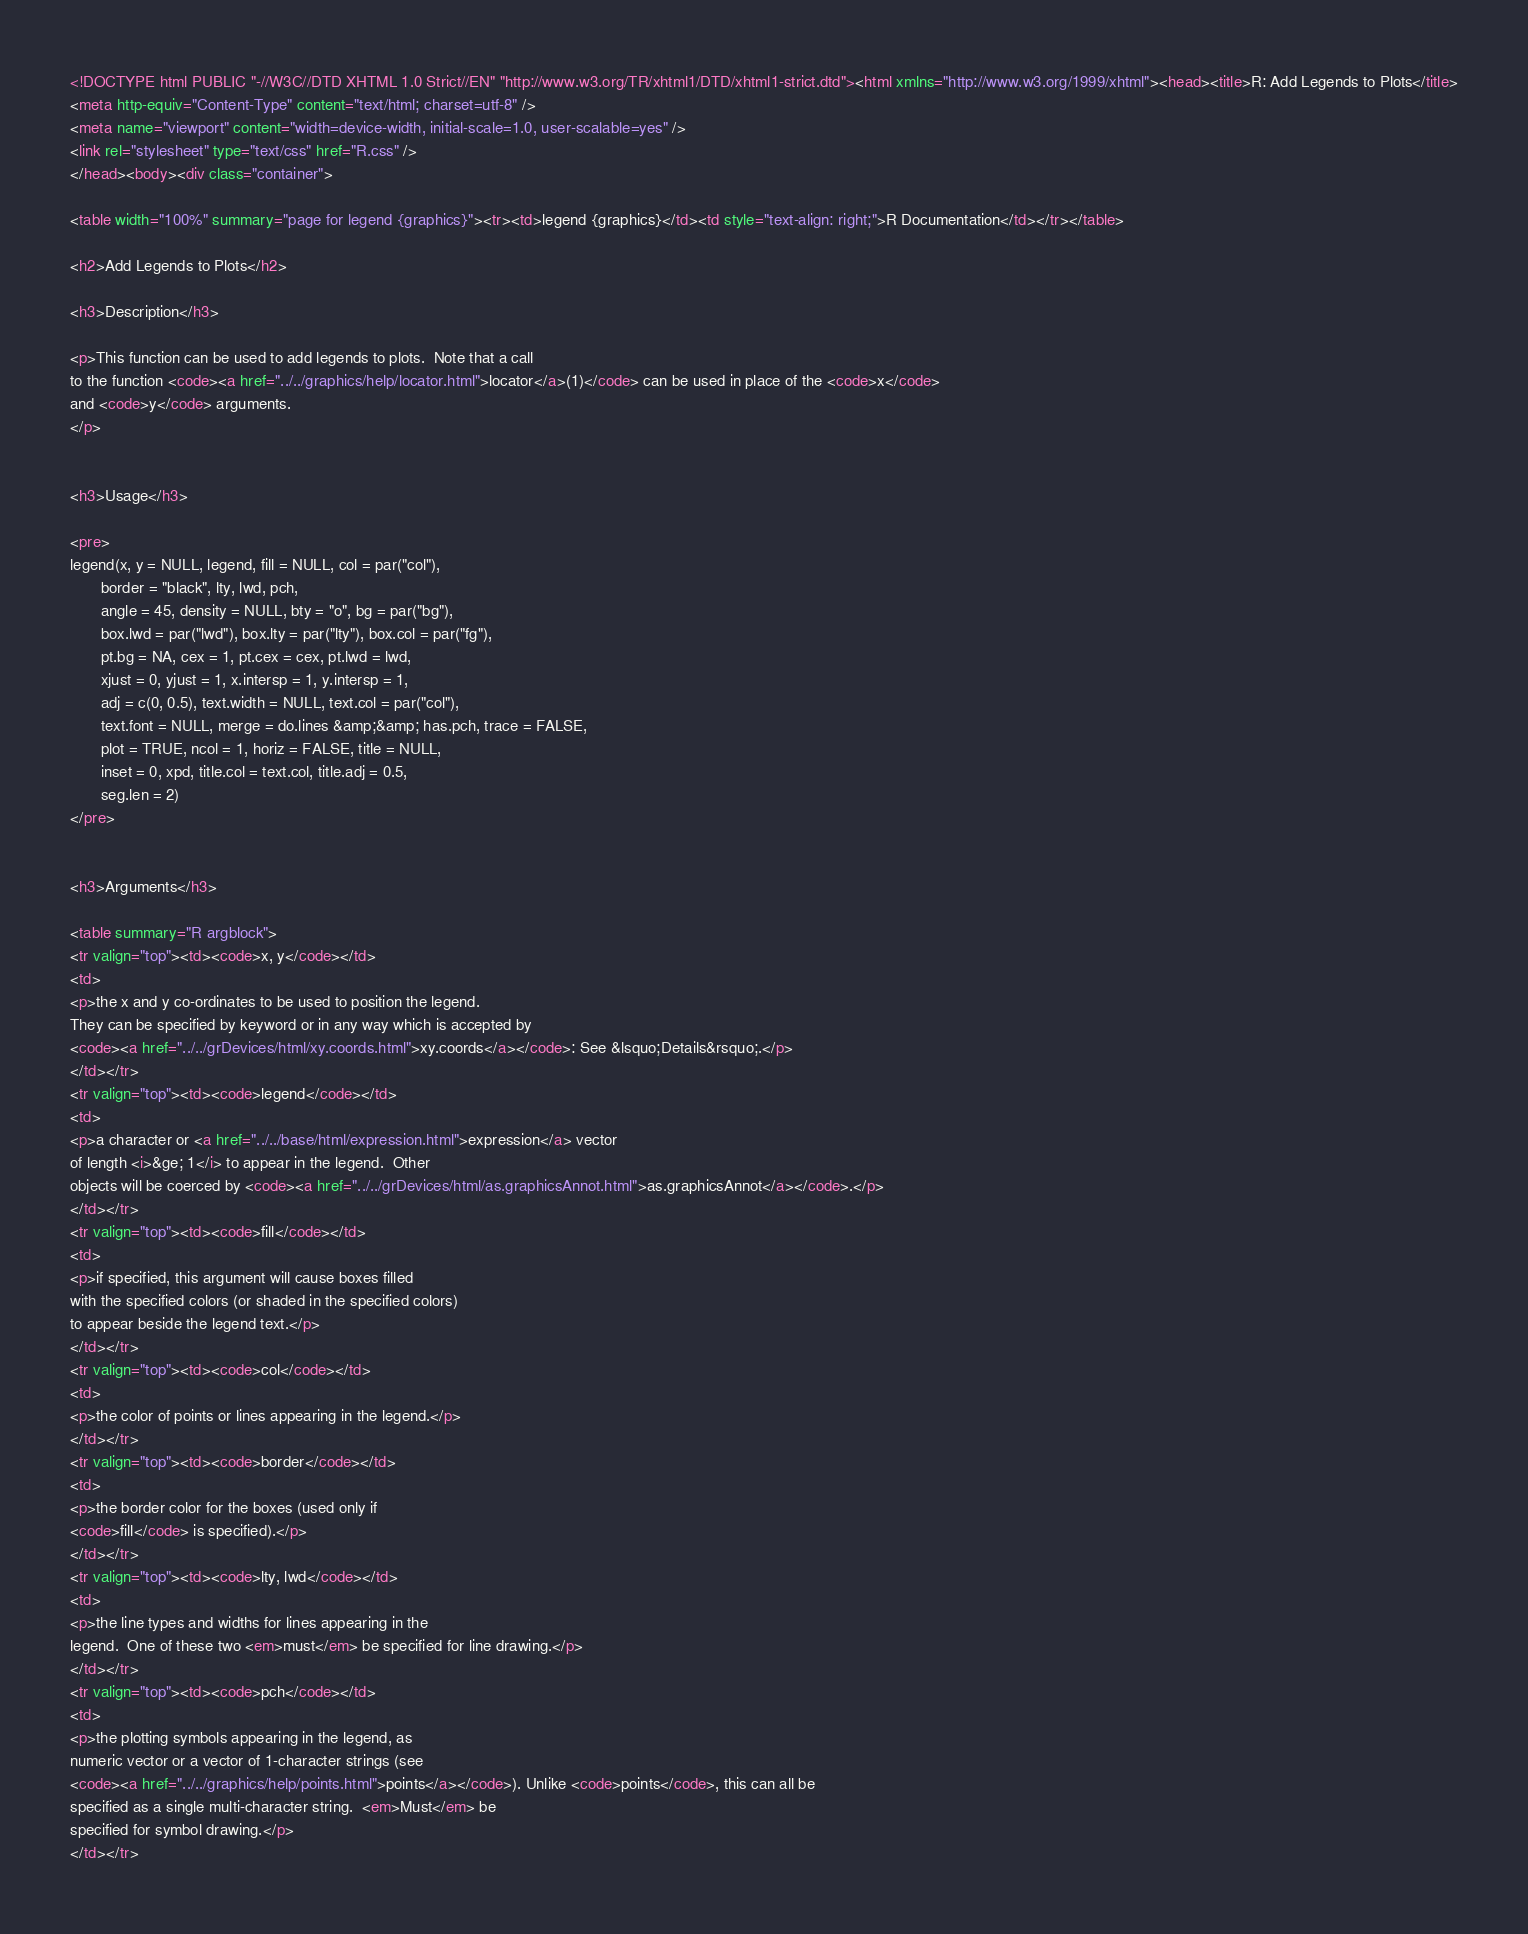Convert code to text. <code><loc_0><loc_0><loc_500><loc_500><_HTML_><!DOCTYPE html PUBLIC "-//W3C//DTD XHTML 1.0 Strict//EN" "http://www.w3.org/TR/xhtml1/DTD/xhtml1-strict.dtd"><html xmlns="http://www.w3.org/1999/xhtml"><head><title>R: Add Legends to Plots</title>
<meta http-equiv="Content-Type" content="text/html; charset=utf-8" />
<meta name="viewport" content="width=device-width, initial-scale=1.0, user-scalable=yes" />
<link rel="stylesheet" type="text/css" href="R.css" />
</head><body><div class="container">

<table width="100%" summary="page for legend {graphics}"><tr><td>legend {graphics}</td><td style="text-align: right;">R Documentation</td></tr></table>

<h2>Add Legends to Plots</h2>

<h3>Description</h3>

<p>This function can be used to add legends to plots.  Note that a call
to the function <code><a href="../../graphics/help/locator.html">locator</a>(1)</code> can be used in place of the <code>x</code>
and <code>y</code> arguments.
</p>


<h3>Usage</h3>

<pre>
legend(x, y = NULL, legend, fill = NULL, col = par("col"),
       border = "black", lty, lwd, pch,
       angle = 45, density = NULL, bty = "o", bg = par("bg"),
       box.lwd = par("lwd"), box.lty = par("lty"), box.col = par("fg"),
       pt.bg = NA, cex = 1, pt.cex = cex, pt.lwd = lwd,
       xjust = 0, yjust = 1, x.intersp = 1, y.intersp = 1,
       adj = c(0, 0.5), text.width = NULL, text.col = par("col"),
       text.font = NULL, merge = do.lines &amp;&amp; has.pch, trace = FALSE,
       plot = TRUE, ncol = 1, horiz = FALSE, title = NULL,
       inset = 0, xpd, title.col = text.col, title.adj = 0.5,
       seg.len = 2)
</pre>


<h3>Arguments</h3>

<table summary="R argblock">
<tr valign="top"><td><code>x, y</code></td>
<td>
<p>the x and y co-ordinates to be used to position the legend.
They can be specified by keyword or in any way which is accepted by
<code><a href="../../grDevices/html/xy.coords.html">xy.coords</a></code>: See &lsquo;Details&rsquo;.</p>
</td></tr>
<tr valign="top"><td><code>legend</code></td>
<td>
<p>a character or <a href="../../base/html/expression.html">expression</a> vector
of length <i>&ge; 1</i> to appear in the legend.  Other
objects will be coerced by <code><a href="../../grDevices/html/as.graphicsAnnot.html">as.graphicsAnnot</a></code>.</p>
</td></tr>
<tr valign="top"><td><code>fill</code></td>
<td>
<p>if specified, this argument will cause boxes filled
with the specified colors (or shaded in the specified colors)
to appear beside the legend text.</p>
</td></tr>
<tr valign="top"><td><code>col</code></td>
<td>
<p>the color of points or lines appearing in the legend.</p>
</td></tr>
<tr valign="top"><td><code>border</code></td>
<td>
<p>the border color for the boxes (used only if
<code>fill</code> is specified).</p>
</td></tr>
<tr valign="top"><td><code>lty, lwd</code></td>
<td>
<p>the line types and widths for lines appearing in the
legend.  One of these two <em>must</em> be specified for line drawing.</p>
</td></tr>
<tr valign="top"><td><code>pch</code></td>
<td>
<p>the plotting symbols appearing in the legend, as
numeric vector or a vector of 1-character strings (see
<code><a href="../../graphics/help/points.html">points</a></code>). Unlike <code>points</code>, this can all be
specified as a single multi-character string.  <em>Must</em> be
specified for symbol drawing.</p>
</td></tr></code> 